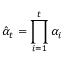<formula> <loc_0><loc_0><loc_500><loc_500>\hat { \alpha } _ { t } = \prod _ { i = 1 } ^ { t } \alpha _ { i }</formula> 